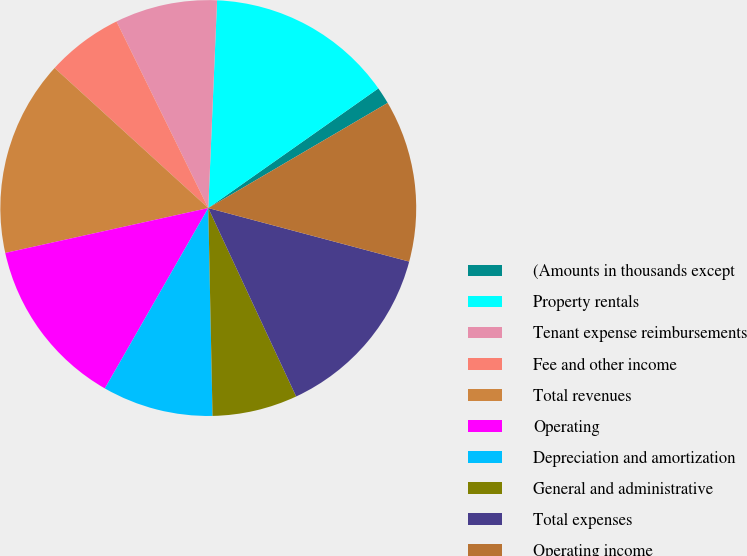<chart> <loc_0><loc_0><loc_500><loc_500><pie_chart><fcel>(Amounts in thousands except<fcel>Property rentals<fcel>Tenant expense reimbursements<fcel>Fee and other income<fcel>Total revenues<fcel>Operating<fcel>Depreciation and amortization<fcel>General and administrative<fcel>Total expenses<fcel>Operating income<nl><fcel>1.32%<fcel>14.57%<fcel>7.95%<fcel>5.96%<fcel>15.23%<fcel>13.25%<fcel>8.61%<fcel>6.62%<fcel>13.91%<fcel>12.58%<nl></chart> 